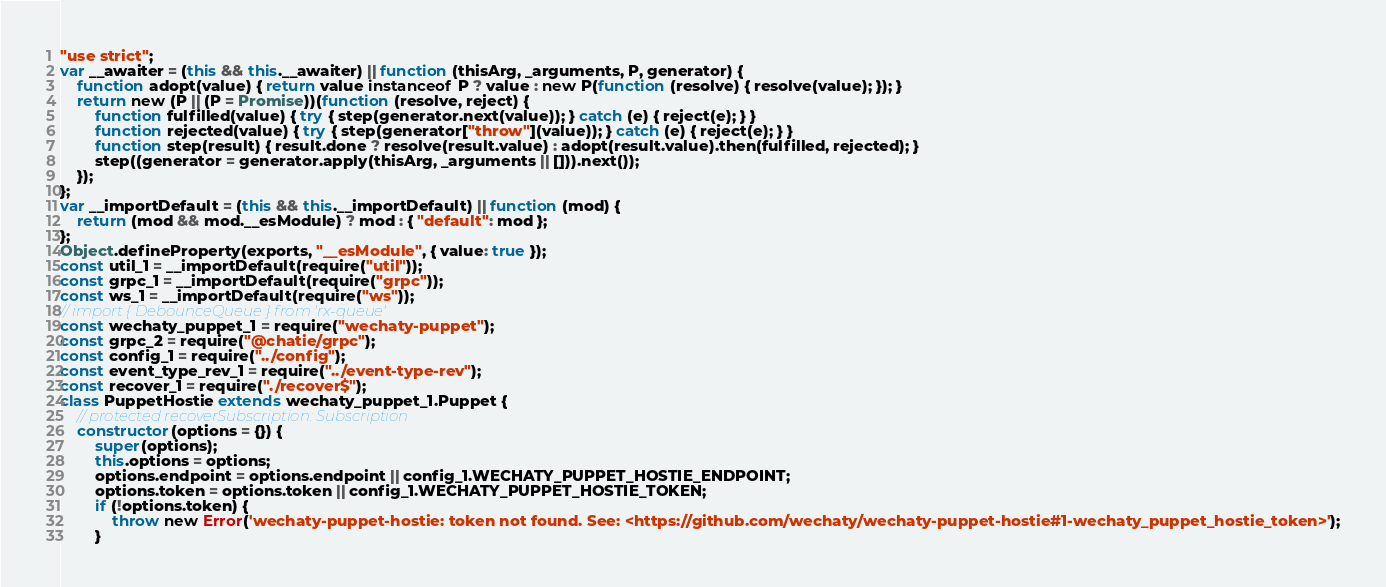Convert code to text. <code><loc_0><loc_0><loc_500><loc_500><_JavaScript_>"use strict";
var __awaiter = (this && this.__awaiter) || function (thisArg, _arguments, P, generator) {
    function adopt(value) { return value instanceof P ? value : new P(function (resolve) { resolve(value); }); }
    return new (P || (P = Promise))(function (resolve, reject) {
        function fulfilled(value) { try { step(generator.next(value)); } catch (e) { reject(e); } }
        function rejected(value) { try { step(generator["throw"](value)); } catch (e) { reject(e); } }
        function step(result) { result.done ? resolve(result.value) : adopt(result.value).then(fulfilled, rejected); }
        step((generator = generator.apply(thisArg, _arguments || [])).next());
    });
};
var __importDefault = (this && this.__importDefault) || function (mod) {
    return (mod && mod.__esModule) ? mod : { "default": mod };
};
Object.defineProperty(exports, "__esModule", { value: true });
const util_1 = __importDefault(require("util"));
const grpc_1 = __importDefault(require("grpc"));
const ws_1 = __importDefault(require("ws"));
// import { DebounceQueue } from 'rx-queue'
const wechaty_puppet_1 = require("wechaty-puppet");
const grpc_2 = require("@chatie/grpc");
const config_1 = require("../config");
const event_type_rev_1 = require("../event-type-rev");
const recover_1 = require("./recover$");
class PuppetHostie extends wechaty_puppet_1.Puppet {
    // protected recoverSubscription: Subscription
    constructor(options = {}) {
        super(options);
        this.options = options;
        options.endpoint = options.endpoint || config_1.WECHATY_PUPPET_HOSTIE_ENDPOINT;
        options.token = options.token || config_1.WECHATY_PUPPET_HOSTIE_TOKEN;
        if (!options.token) {
            throw new Error('wechaty-puppet-hostie: token not found. See: <https://github.com/wechaty/wechaty-puppet-hostie#1-wechaty_puppet_hostie_token>');
        }</code> 